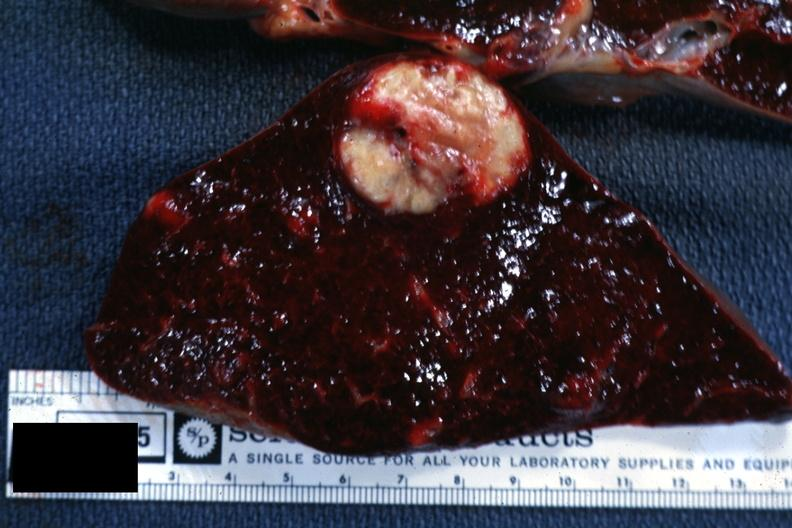s this photo of infant from head to toe present?
Answer the question using a single word or phrase. No 